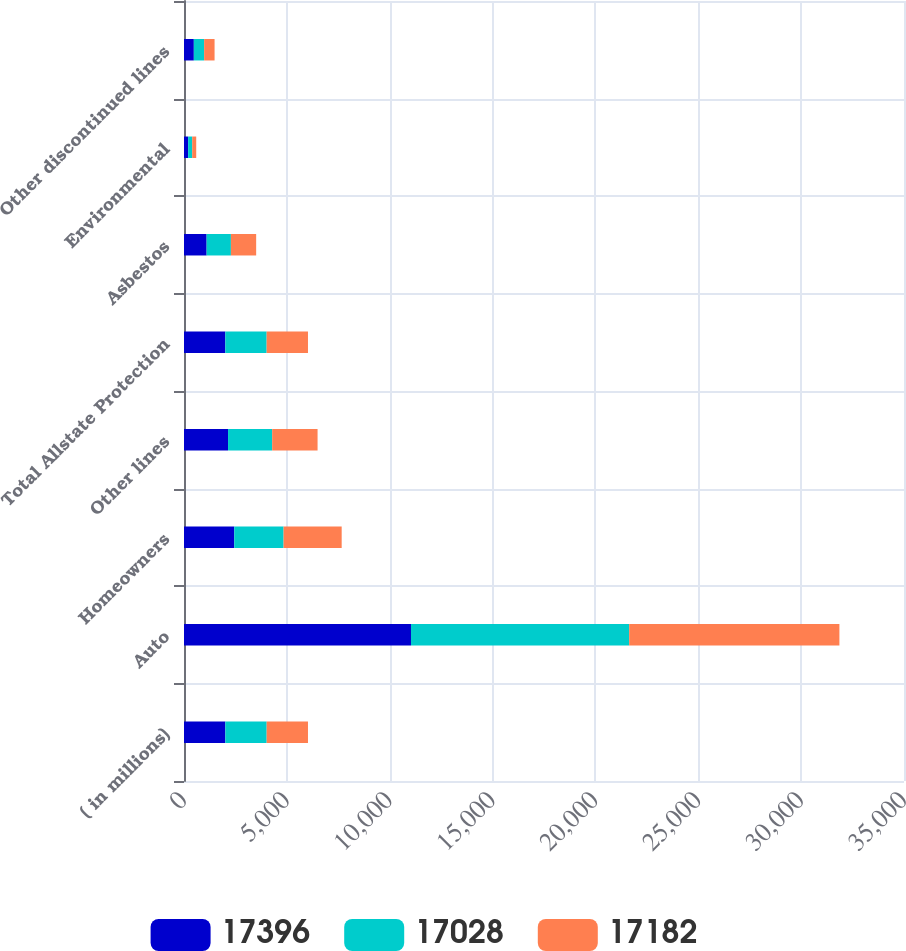Convert chart to OTSL. <chart><loc_0><loc_0><loc_500><loc_500><stacked_bar_chart><ecel><fcel>( in millions)<fcel>Auto<fcel>Homeowners<fcel>Other lines<fcel>Total Allstate Protection<fcel>Asbestos<fcel>Environmental<fcel>Other discontinued lines<nl><fcel>17396<fcel>2010<fcel>11034<fcel>2442<fcel>2141<fcel>2009<fcel>1100<fcel>201<fcel>478<nl><fcel>17028<fcel>2009<fcel>10606<fcel>2399<fcel>2145<fcel>2009<fcel>1180<fcel>198<fcel>500<nl><fcel>17182<fcel>2008<fcel>10220<fcel>2824<fcel>2207<fcel>2009<fcel>1228<fcel>195<fcel>508<nl></chart> 